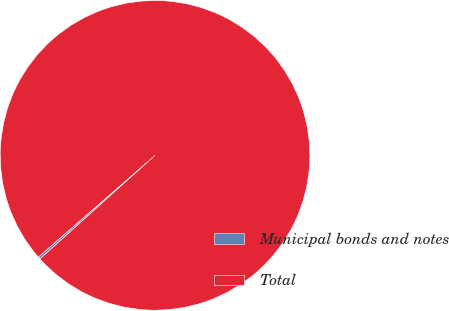Convert chart to OTSL. <chart><loc_0><loc_0><loc_500><loc_500><pie_chart><fcel>Municipal bonds and notes<fcel>Total<nl><fcel>0.25%<fcel>99.75%<nl></chart> 